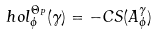Convert formula to latex. <formula><loc_0><loc_0><loc_500><loc_500>h o l _ { \phi } ^ { \Theta _ { P } } ( \gamma ) = - C S ( A _ { \phi } ^ { \gamma } )</formula> 